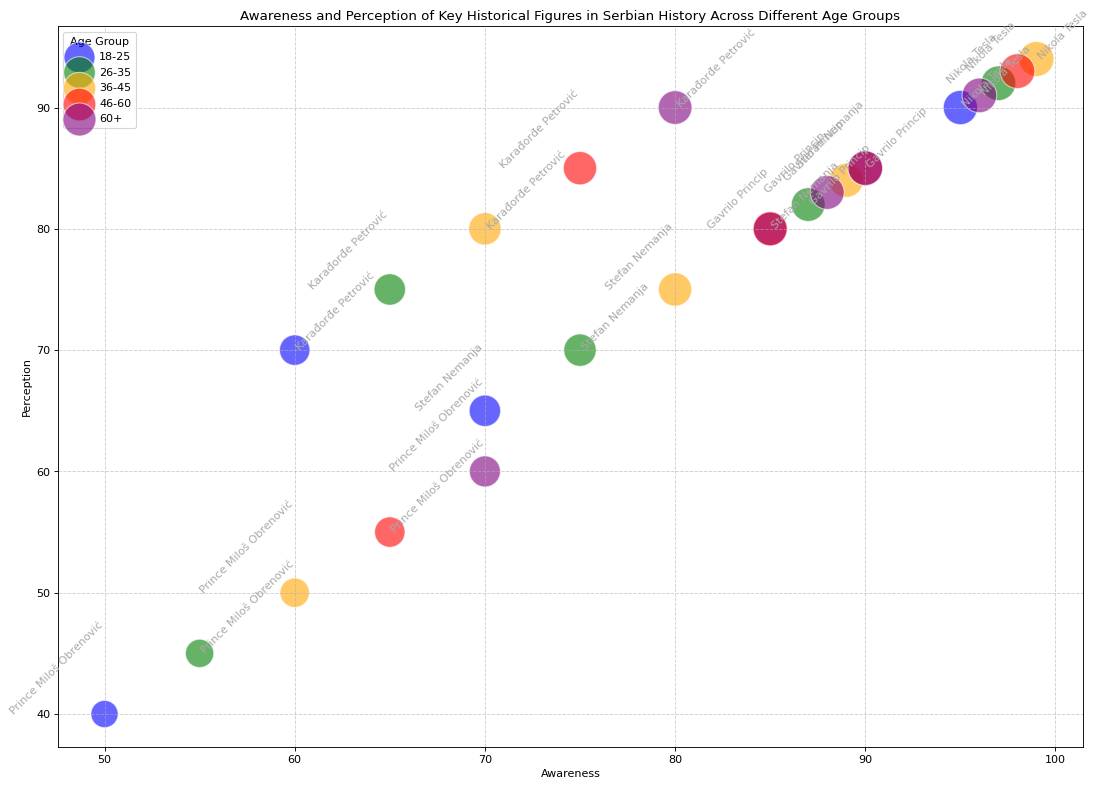What is the average awareness of Stefan Nemanja across all age groups? To calculate the average awareness, sum the awareness values of Stefan Nemanja across all age groups and divide by the number of age groups. The awareness values are 70, 75, 80, 85, and 90. The sum is 70 + 75 + 80 + 85 + 90 = 400. There are 5 age groups, so the average is 400 / 5 = 80
Answer: 80 Which historical figure has the highest perception among the 36-45 age group? Look at the perception values for the 36-45 age group. Identify which historical figure has the highest value. The perception values are Stefan Nemanja (75), Karađorđe Petrović (80), Prince Miloš Obrenović (50), Nikola Tesla (94), and Gavrilo Princip (84). Nikola Tesla has the highest perception of 94
Answer: Nikola Tesla Compare the perception of Gavrilo Princip and Prince Miloš Obrenović across the 18-25 and 46-60 age groups. Who has a higher perception in both groups? For the 18-25 group, the perception of Gavrilo Princip is 80 and for Prince Miloš Obrenović is 40. For the 46-60 group, the perception of Gavrilo Princip is 85 and for Prince Miloš Obrenović is 55. In both age groups, Gavrilo Princip has a higher perception
Answer: Gavrilo Princip What is the sum of the importance values for Nikola Tesla across all age groups? Sum the importance values for Nikola Tesla: 95 (18-25), 97 (26-35), 99 (36-45), 98 (46-60), and 97 (60+). The sum is 95 + 97 + 99 + 98 + 97 = 486
Answer: 486 Which age group shows the highest awareness for Prince Miloš Obrenović? Look at the awareness values for Prince Miloš Obrenović across all age groups. The values are 18-25 (50), 26-35 (55), 36-45 (60), 46-60 (65), and 60+ (70). The highest awareness is in the 60+ age group with a value of 70
Answer: 60+ What is the difference in perception between Nikola Tesla and Karađorđe Petrović in the 26-35 age group? Look at the perception values for both historical figures in the 26-35 age group. Nikola Tesla has a perception of 92 and Karađorđe Petrović has a perception of 75. The difference is 92 - 75 = 17
Answer: 17 Which age group has the smallest importance value for Stefana Nemanju and what is the value? Examine the importance values for Stefan Nemanja across all age groups. The values are: 80 (18-25), 85 (26-35), 90 (36-45), 95 (46-60), and 98 (60+). The smallest importance value is 80 in the 18-25 age group
Answer: 18-25, 80 Among the 60+ age group, who has a higher perception, Karađorđe Petrović or Gavrilo Princip? For the 60+ age group, check the perception values. Karađorđe Petrović has a perception of 90 and Gavrilo Princip has a perception of 83. Karađorđe Petrović has a higher perception
Answer: Karađorđe Petrović 